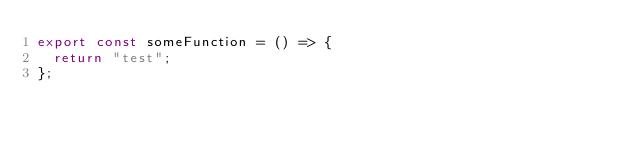<code> <loc_0><loc_0><loc_500><loc_500><_TypeScript_>export const someFunction = () => {
  return "test";
};
</code> 